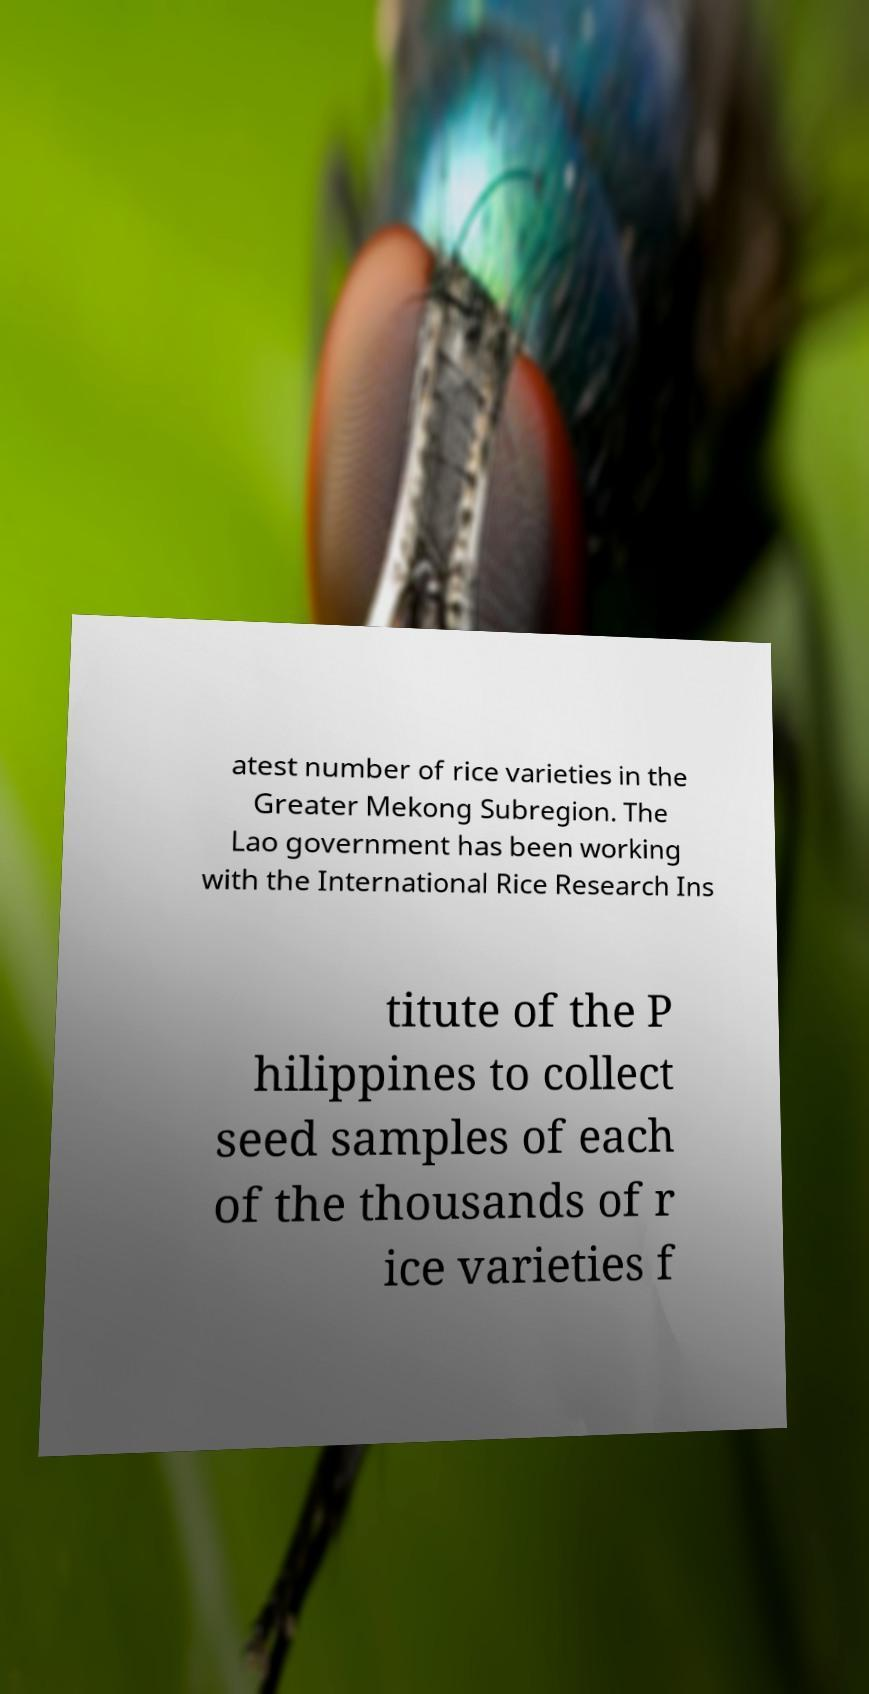I need the written content from this picture converted into text. Can you do that? atest number of rice varieties in the Greater Mekong Subregion. The Lao government has been working with the International Rice Research Ins titute of the P hilippines to collect seed samples of each of the thousands of r ice varieties f 